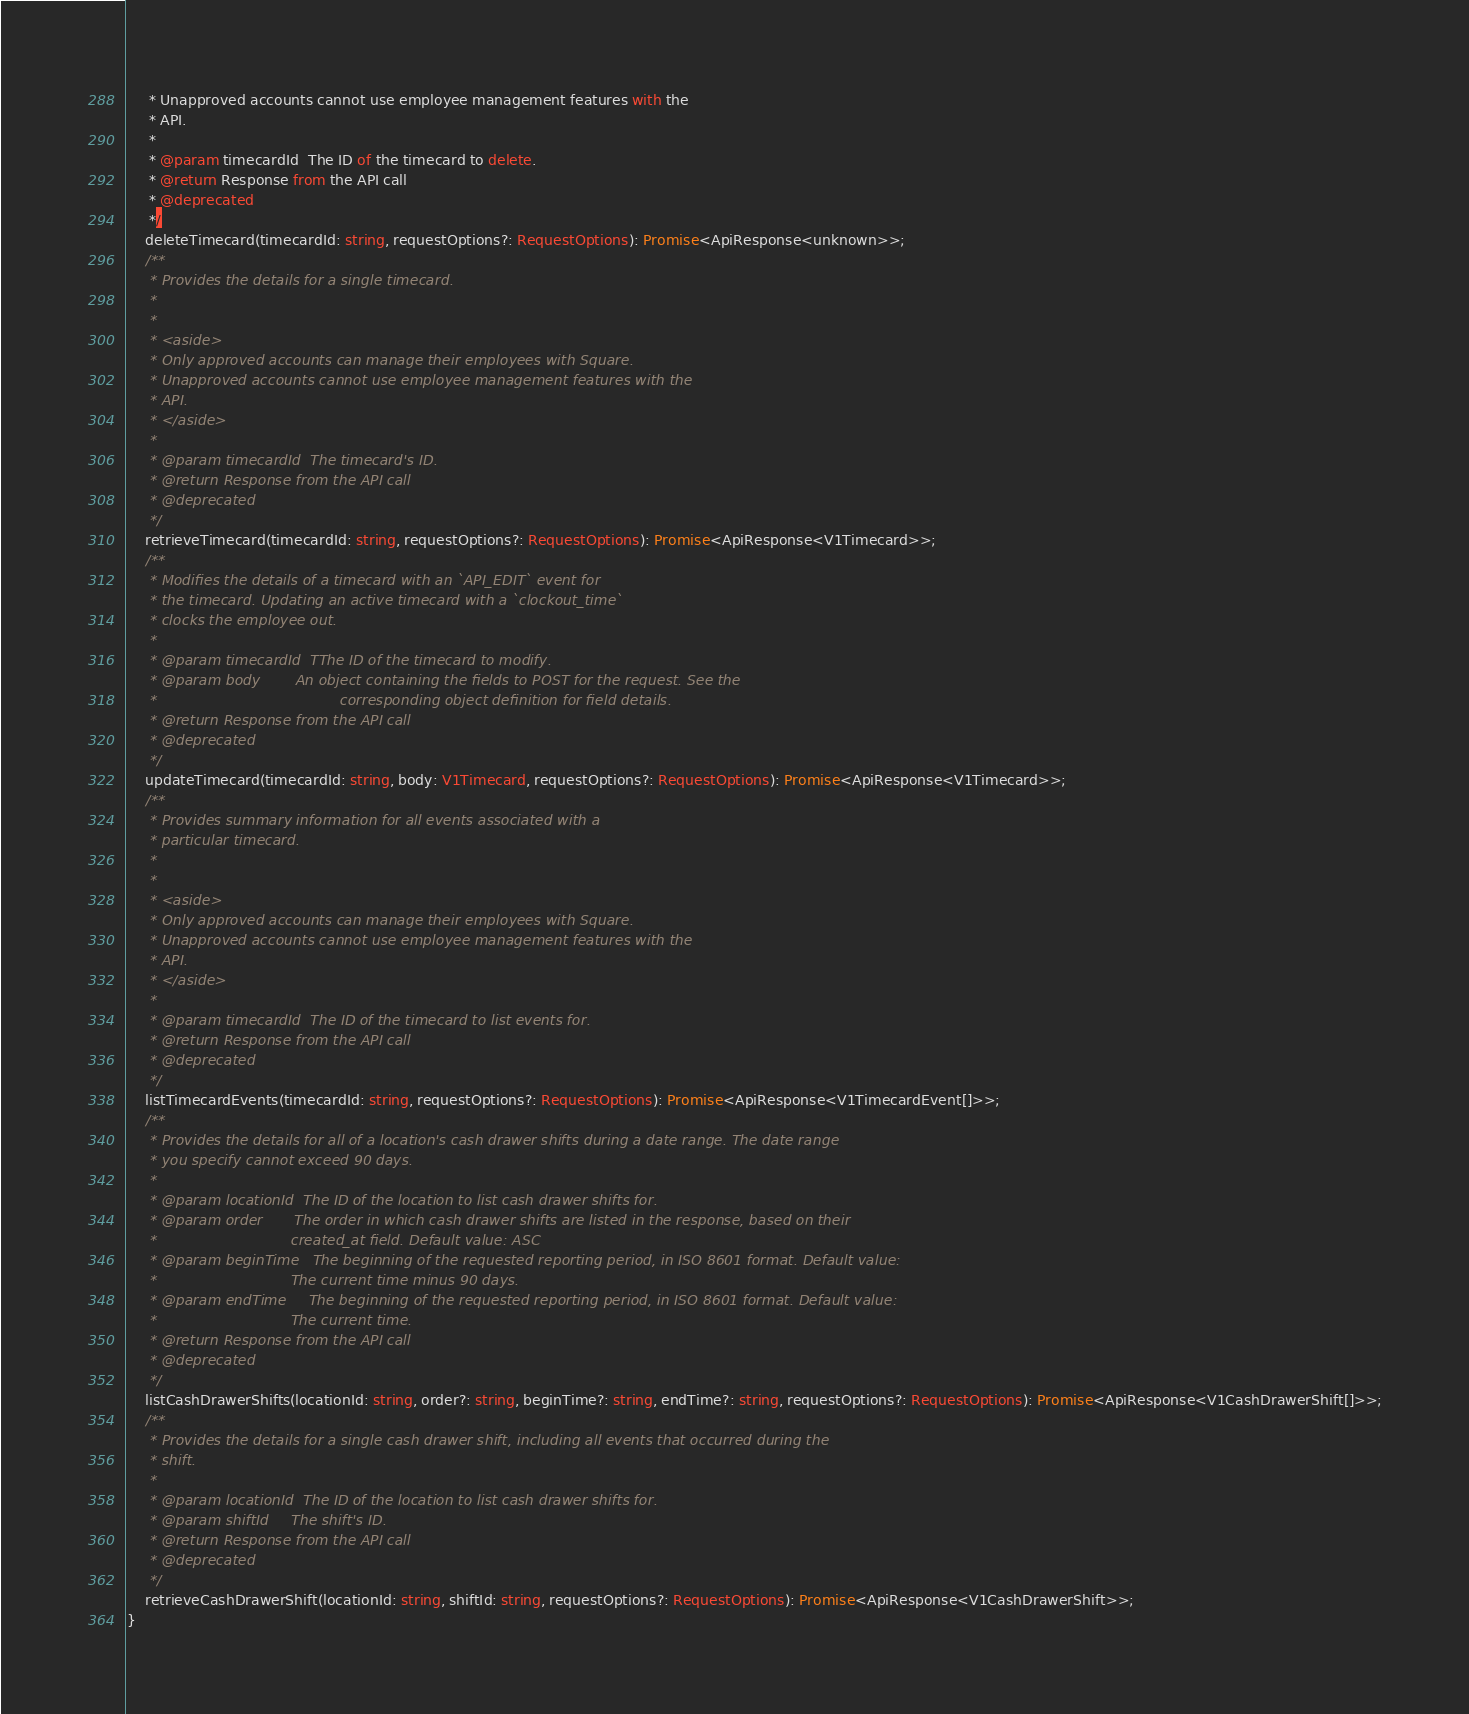Convert code to text. <code><loc_0><loc_0><loc_500><loc_500><_TypeScript_>     * Unapproved accounts cannot use employee management features with the
     * API.
     *
     * @param timecardId  The ID of the timecard to delete.
     * @return Response from the API call
     * @deprecated
     */
    deleteTimecard(timecardId: string, requestOptions?: RequestOptions): Promise<ApiResponse<unknown>>;
    /**
     * Provides the details for a single timecard.
     *
     *
     * <aside>
     * Only approved accounts can manage their employees with Square.
     * Unapproved accounts cannot use employee management features with the
     * API.
     * </aside>
     *
     * @param timecardId  The timecard's ID.
     * @return Response from the API call
     * @deprecated
     */
    retrieveTimecard(timecardId: string, requestOptions?: RequestOptions): Promise<ApiResponse<V1Timecard>>;
    /**
     * Modifies the details of a timecard with an `API_EDIT` event for
     * the timecard. Updating an active timecard with a `clockout_time`
     * clocks the employee out.
     *
     * @param timecardId  TThe ID of the timecard to modify.
     * @param body        An object containing the fields to POST for the request. See the
     *                                         corresponding object definition for field details.
     * @return Response from the API call
     * @deprecated
     */
    updateTimecard(timecardId: string, body: V1Timecard, requestOptions?: RequestOptions): Promise<ApiResponse<V1Timecard>>;
    /**
     * Provides summary information for all events associated with a
     * particular timecard.
     *
     *
     * <aside>
     * Only approved accounts can manage their employees with Square.
     * Unapproved accounts cannot use employee management features with the
     * API.
     * </aside>
     *
     * @param timecardId  The ID of the timecard to list events for.
     * @return Response from the API call
     * @deprecated
     */
    listTimecardEvents(timecardId: string, requestOptions?: RequestOptions): Promise<ApiResponse<V1TimecardEvent[]>>;
    /**
     * Provides the details for all of a location's cash drawer shifts during a date range. The date range
     * you specify cannot exceed 90 days.
     *
     * @param locationId  The ID of the location to list cash drawer shifts for.
     * @param order       The order in which cash drawer shifts are listed in the response, based on their
     *                              created_at field. Default value: ASC
     * @param beginTime   The beginning of the requested reporting period, in ISO 8601 format. Default value:
     *                              The current time minus 90 days.
     * @param endTime     The beginning of the requested reporting period, in ISO 8601 format. Default value:
     *                              The current time.
     * @return Response from the API call
     * @deprecated
     */
    listCashDrawerShifts(locationId: string, order?: string, beginTime?: string, endTime?: string, requestOptions?: RequestOptions): Promise<ApiResponse<V1CashDrawerShift[]>>;
    /**
     * Provides the details for a single cash drawer shift, including all events that occurred during the
     * shift.
     *
     * @param locationId  The ID of the location to list cash drawer shifts for.
     * @param shiftId     The shift's ID.
     * @return Response from the API call
     * @deprecated
     */
    retrieveCashDrawerShift(locationId: string, shiftId: string, requestOptions?: RequestOptions): Promise<ApiResponse<V1CashDrawerShift>>;
}
</code> 